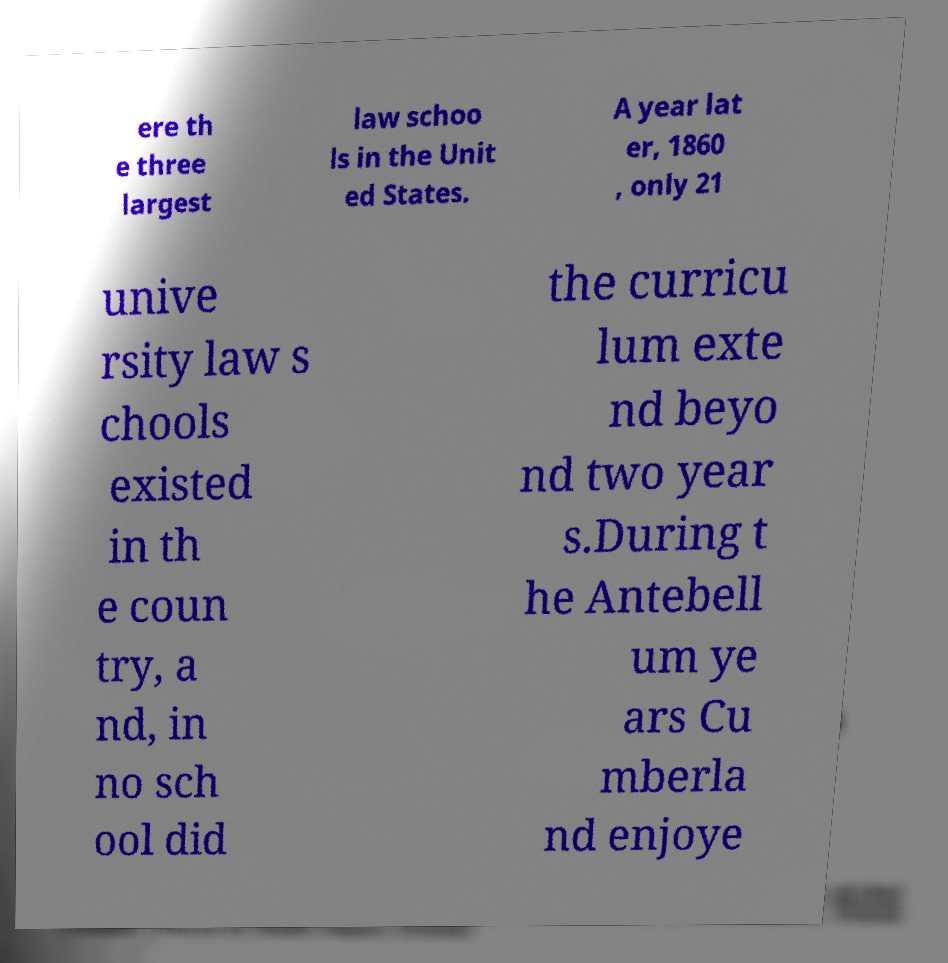Please identify and transcribe the text found in this image. ere th e three largest law schoo ls in the Unit ed States. A year lat er, 1860 , only 21 unive rsity law s chools existed in th e coun try, a nd, in no sch ool did the curricu lum exte nd beyo nd two year s.During t he Antebell um ye ars Cu mberla nd enjoye 